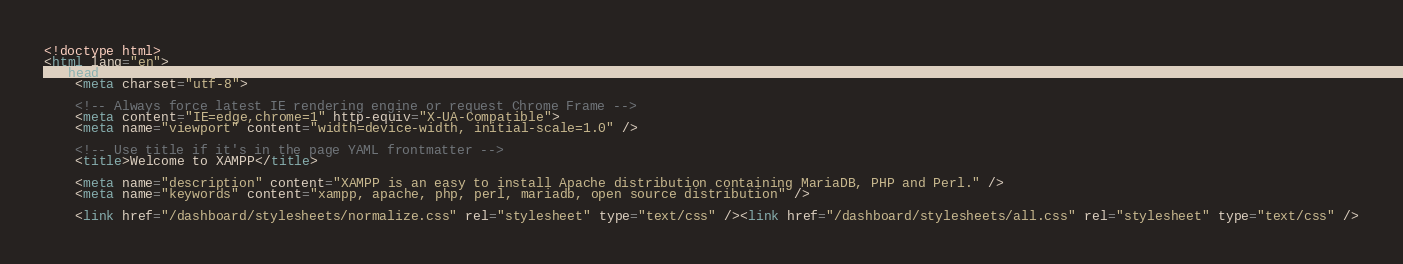Convert code to text. <code><loc_0><loc_0><loc_500><loc_500><_HTML_><!doctype html>
<html lang="en">
  <head>
    <meta charset="utf-8">

    <!-- Always force latest IE rendering engine or request Chrome Frame -->
    <meta content="IE=edge,chrome=1" http-equiv="X-UA-Compatible">
    <meta name="viewport" content="width=device-width, initial-scale=1.0" />

    <!-- Use title if it's in the page YAML frontmatter -->
    <title>Welcome to XAMPP</title>

    <meta name="description" content="XAMPP is an easy to install Apache distribution containing MariaDB, PHP and Perl." />
    <meta name="keywords" content="xampp, apache, php, perl, mariadb, open source distribution" />

    <link href="/dashboard/stylesheets/normalize.css" rel="stylesheet" type="text/css" /><link href="/dashboard/stylesheets/all.css" rel="stylesheet" type="text/css" /></code> 